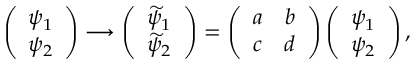<formula> <loc_0><loc_0><loc_500><loc_500>\left ( \begin{array} { c } { { \psi _ { 1 } } } \\ { { \psi _ { 2 } } } \end{array} \right ) \longrightarrow \left ( \begin{array} { c } { { \widetilde { \psi } _ { 1 } } } \\ { { \widetilde { \psi } _ { 2 } } } \end{array} \right ) = \left ( \begin{array} { c } { a } \\ { c } \end{array} \begin{array} { c c } { b } \\ { d } \end{array} \right ) \left ( \begin{array} { c } { { \psi _ { 1 } } } \\ { { \psi _ { 2 } } } \end{array} \right ) ,</formula> 